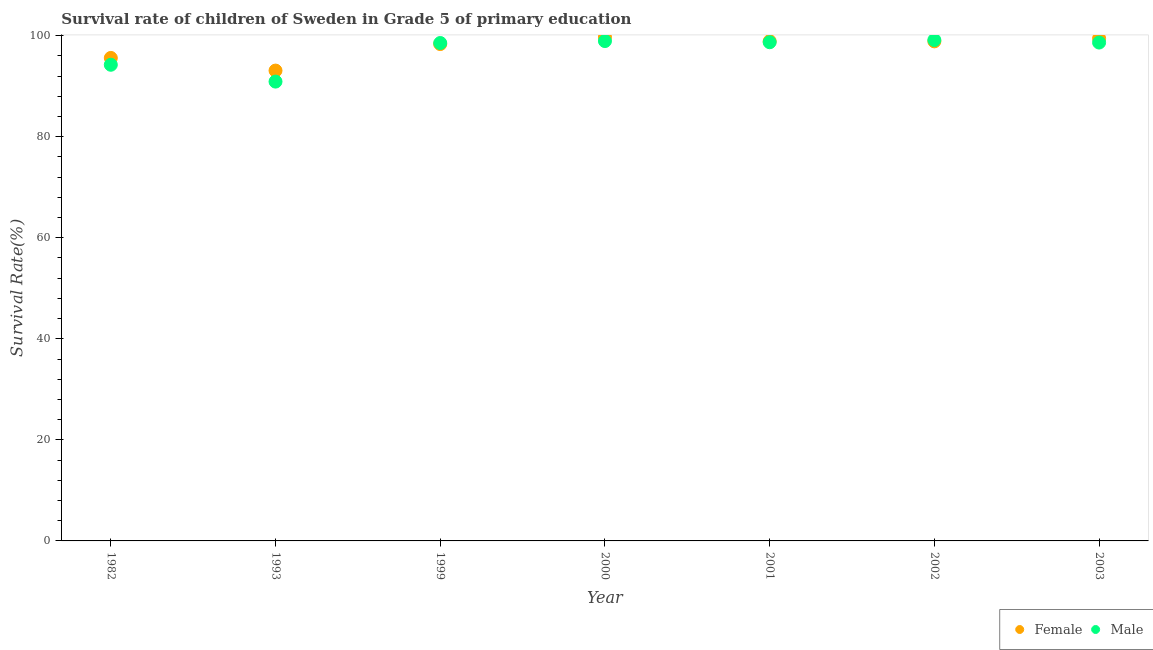How many different coloured dotlines are there?
Your answer should be very brief. 2. What is the survival rate of female students in primary education in 2001?
Keep it short and to the point. 98.9. Across all years, what is the maximum survival rate of female students in primary education?
Your response must be concise. 99.7. Across all years, what is the minimum survival rate of male students in primary education?
Provide a succinct answer. 90.9. What is the total survival rate of male students in primary education in the graph?
Your answer should be compact. 679.03. What is the difference between the survival rate of male students in primary education in 1982 and that in 2000?
Keep it short and to the point. -4.69. What is the difference between the survival rate of male students in primary education in 1982 and the survival rate of female students in primary education in 2001?
Ensure brevity in your answer.  -4.67. What is the average survival rate of female students in primary education per year?
Your answer should be very brief. 97.7. In the year 1982, what is the difference between the survival rate of male students in primary education and survival rate of female students in primary education?
Ensure brevity in your answer.  -1.35. In how many years, is the survival rate of female students in primary education greater than 64 %?
Offer a terse response. 7. What is the ratio of the survival rate of male students in primary education in 2000 to that in 2003?
Give a very brief answer. 1. Is the survival rate of female students in primary education in 2001 less than that in 2003?
Your response must be concise. Yes. What is the difference between the highest and the second highest survival rate of female students in primary education?
Provide a short and direct response. 0.26. What is the difference between the highest and the lowest survival rate of male students in primary education?
Your answer should be compact. 8.23. In how many years, is the survival rate of female students in primary education greater than the average survival rate of female students in primary education taken over all years?
Keep it short and to the point. 5. Does the survival rate of male students in primary education monotonically increase over the years?
Your response must be concise. No. Is the survival rate of female students in primary education strictly greater than the survival rate of male students in primary education over the years?
Offer a terse response. No. How many dotlines are there?
Offer a very short reply. 2. How many years are there in the graph?
Provide a succinct answer. 7. What is the difference between two consecutive major ticks on the Y-axis?
Make the answer very short. 20. How are the legend labels stacked?
Offer a terse response. Horizontal. What is the title of the graph?
Make the answer very short. Survival rate of children of Sweden in Grade 5 of primary education. Does "Lowest 20% of population" appear as one of the legend labels in the graph?
Offer a very short reply. No. What is the label or title of the Y-axis?
Offer a terse response. Survival Rate(%). What is the Survival Rate(%) of Female in 1982?
Your answer should be compact. 95.58. What is the Survival Rate(%) in Male in 1982?
Make the answer very short. 94.23. What is the Survival Rate(%) in Female in 1993?
Your answer should be compact. 93.08. What is the Survival Rate(%) in Male in 1993?
Offer a very short reply. 90.9. What is the Survival Rate(%) of Female in 1999?
Your response must be concise. 98.33. What is the Survival Rate(%) in Male in 1999?
Keep it short and to the point. 98.54. What is the Survival Rate(%) of Female in 2000?
Ensure brevity in your answer.  99.7. What is the Survival Rate(%) in Male in 2000?
Keep it short and to the point. 98.92. What is the Survival Rate(%) of Female in 2001?
Ensure brevity in your answer.  98.9. What is the Survival Rate(%) in Male in 2001?
Offer a very short reply. 98.69. What is the Survival Rate(%) in Female in 2002?
Provide a succinct answer. 98.86. What is the Survival Rate(%) in Male in 2002?
Provide a succinct answer. 99.13. What is the Survival Rate(%) of Female in 2003?
Offer a very short reply. 99.45. What is the Survival Rate(%) in Male in 2003?
Your answer should be compact. 98.63. Across all years, what is the maximum Survival Rate(%) in Female?
Offer a very short reply. 99.7. Across all years, what is the maximum Survival Rate(%) in Male?
Ensure brevity in your answer.  99.13. Across all years, what is the minimum Survival Rate(%) of Female?
Your answer should be compact. 93.08. Across all years, what is the minimum Survival Rate(%) in Male?
Your response must be concise. 90.9. What is the total Survival Rate(%) of Female in the graph?
Offer a very short reply. 683.9. What is the total Survival Rate(%) of Male in the graph?
Give a very brief answer. 679.03. What is the difference between the Survival Rate(%) of Female in 1982 and that in 1993?
Your answer should be very brief. 2.5. What is the difference between the Survival Rate(%) in Male in 1982 and that in 1993?
Provide a short and direct response. 3.33. What is the difference between the Survival Rate(%) of Female in 1982 and that in 1999?
Offer a very short reply. -2.74. What is the difference between the Survival Rate(%) in Male in 1982 and that in 1999?
Offer a terse response. -4.3. What is the difference between the Survival Rate(%) of Female in 1982 and that in 2000?
Offer a very short reply. -4.12. What is the difference between the Survival Rate(%) of Male in 1982 and that in 2000?
Your answer should be compact. -4.69. What is the difference between the Survival Rate(%) in Female in 1982 and that in 2001?
Offer a very short reply. -3.31. What is the difference between the Survival Rate(%) in Male in 1982 and that in 2001?
Make the answer very short. -4.46. What is the difference between the Survival Rate(%) in Female in 1982 and that in 2002?
Provide a succinct answer. -3.28. What is the difference between the Survival Rate(%) in Male in 1982 and that in 2002?
Your response must be concise. -4.9. What is the difference between the Survival Rate(%) in Female in 1982 and that in 2003?
Your answer should be compact. -3.86. What is the difference between the Survival Rate(%) of Male in 1982 and that in 2003?
Ensure brevity in your answer.  -4.4. What is the difference between the Survival Rate(%) in Female in 1993 and that in 1999?
Your response must be concise. -5.25. What is the difference between the Survival Rate(%) in Male in 1993 and that in 1999?
Offer a very short reply. -7.64. What is the difference between the Survival Rate(%) in Female in 1993 and that in 2000?
Provide a short and direct response. -6.63. What is the difference between the Survival Rate(%) in Male in 1993 and that in 2000?
Your answer should be compact. -8.02. What is the difference between the Survival Rate(%) of Female in 1993 and that in 2001?
Your response must be concise. -5.82. What is the difference between the Survival Rate(%) in Male in 1993 and that in 2001?
Make the answer very short. -7.79. What is the difference between the Survival Rate(%) of Female in 1993 and that in 2002?
Give a very brief answer. -5.78. What is the difference between the Survival Rate(%) of Male in 1993 and that in 2002?
Ensure brevity in your answer.  -8.23. What is the difference between the Survival Rate(%) of Female in 1993 and that in 2003?
Keep it short and to the point. -6.37. What is the difference between the Survival Rate(%) in Male in 1993 and that in 2003?
Your response must be concise. -7.73. What is the difference between the Survival Rate(%) in Female in 1999 and that in 2000?
Make the answer very short. -1.38. What is the difference between the Survival Rate(%) of Male in 1999 and that in 2000?
Your answer should be very brief. -0.39. What is the difference between the Survival Rate(%) of Female in 1999 and that in 2001?
Provide a succinct answer. -0.57. What is the difference between the Survival Rate(%) of Male in 1999 and that in 2001?
Offer a terse response. -0.15. What is the difference between the Survival Rate(%) of Female in 1999 and that in 2002?
Give a very brief answer. -0.54. What is the difference between the Survival Rate(%) in Male in 1999 and that in 2002?
Offer a terse response. -0.59. What is the difference between the Survival Rate(%) in Female in 1999 and that in 2003?
Provide a succinct answer. -1.12. What is the difference between the Survival Rate(%) of Male in 1999 and that in 2003?
Your answer should be compact. -0.09. What is the difference between the Survival Rate(%) in Female in 2000 and that in 2001?
Offer a very short reply. 0.81. What is the difference between the Survival Rate(%) in Male in 2000 and that in 2001?
Give a very brief answer. 0.23. What is the difference between the Survival Rate(%) of Female in 2000 and that in 2002?
Provide a short and direct response. 0.84. What is the difference between the Survival Rate(%) of Male in 2000 and that in 2002?
Ensure brevity in your answer.  -0.21. What is the difference between the Survival Rate(%) in Female in 2000 and that in 2003?
Your answer should be compact. 0.26. What is the difference between the Survival Rate(%) in Male in 2000 and that in 2003?
Ensure brevity in your answer.  0.29. What is the difference between the Survival Rate(%) in Female in 2001 and that in 2002?
Ensure brevity in your answer.  0.04. What is the difference between the Survival Rate(%) in Male in 2001 and that in 2002?
Your response must be concise. -0.44. What is the difference between the Survival Rate(%) of Female in 2001 and that in 2003?
Provide a short and direct response. -0.55. What is the difference between the Survival Rate(%) in Male in 2001 and that in 2003?
Provide a short and direct response. 0.06. What is the difference between the Survival Rate(%) in Female in 2002 and that in 2003?
Keep it short and to the point. -0.58. What is the difference between the Survival Rate(%) of Male in 2002 and that in 2003?
Your answer should be compact. 0.5. What is the difference between the Survival Rate(%) of Female in 1982 and the Survival Rate(%) of Male in 1993?
Your answer should be compact. 4.68. What is the difference between the Survival Rate(%) in Female in 1982 and the Survival Rate(%) in Male in 1999?
Provide a succinct answer. -2.95. What is the difference between the Survival Rate(%) in Female in 1982 and the Survival Rate(%) in Male in 2000?
Your response must be concise. -3.34. What is the difference between the Survival Rate(%) of Female in 1982 and the Survival Rate(%) of Male in 2001?
Offer a very short reply. -3.1. What is the difference between the Survival Rate(%) of Female in 1982 and the Survival Rate(%) of Male in 2002?
Your response must be concise. -3.54. What is the difference between the Survival Rate(%) in Female in 1982 and the Survival Rate(%) in Male in 2003?
Keep it short and to the point. -3.04. What is the difference between the Survival Rate(%) of Female in 1993 and the Survival Rate(%) of Male in 1999?
Provide a succinct answer. -5.46. What is the difference between the Survival Rate(%) of Female in 1993 and the Survival Rate(%) of Male in 2000?
Ensure brevity in your answer.  -5.84. What is the difference between the Survival Rate(%) in Female in 1993 and the Survival Rate(%) in Male in 2001?
Provide a short and direct response. -5.61. What is the difference between the Survival Rate(%) of Female in 1993 and the Survival Rate(%) of Male in 2002?
Your response must be concise. -6.05. What is the difference between the Survival Rate(%) of Female in 1993 and the Survival Rate(%) of Male in 2003?
Provide a succinct answer. -5.55. What is the difference between the Survival Rate(%) of Female in 1999 and the Survival Rate(%) of Male in 2000?
Your response must be concise. -0.6. What is the difference between the Survival Rate(%) of Female in 1999 and the Survival Rate(%) of Male in 2001?
Give a very brief answer. -0.36. What is the difference between the Survival Rate(%) in Female in 1999 and the Survival Rate(%) in Male in 2002?
Your answer should be very brief. -0.8. What is the difference between the Survival Rate(%) in Female in 1999 and the Survival Rate(%) in Male in 2003?
Give a very brief answer. -0.3. What is the difference between the Survival Rate(%) of Female in 2000 and the Survival Rate(%) of Male in 2001?
Provide a succinct answer. 1.02. What is the difference between the Survival Rate(%) in Female in 2000 and the Survival Rate(%) in Male in 2002?
Make the answer very short. 0.58. What is the difference between the Survival Rate(%) in Female in 2000 and the Survival Rate(%) in Male in 2003?
Your answer should be very brief. 1.08. What is the difference between the Survival Rate(%) in Female in 2001 and the Survival Rate(%) in Male in 2002?
Your answer should be compact. -0.23. What is the difference between the Survival Rate(%) in Female in 2001 and the Survival Rate(%) in Male in 2003?
Make the answer very short. 0.27. What is the difference between the Survival Rate(%) in Female in 2002 and the Survival Rate(%) in Male in 2003?
Offer a terse response. 0.23. What is the average Survival Rate(%) in Female per year?
Provide a succinct answer. 97.7. What is the average Survival Rate(%) of Male per year?
Offer a very short reply. 97. In the year 1982, what is the difference between the Survival Rate(%) of Female and Survival Rate(%) of Male?
Offer a terse response. 1.35. In the year 1993, what is the difference between the Survival Rate(%) of Female and Survival Rate(%) of Male?
Give a very brief answer. 2.18. In the year 1999, what is the difference between the Survival Rate(%) in Female and Survival Rate(%) in Male?
Keep it short and to the point. -0.21. In the year 2000, what is the difference between the Survival Rate(%) in Female and Survival Rate(%) in Male?
Provide a short and direct response. 0.78. In the year 2001, what is the difference between the Survival Rate(%) in Female and Survival Rate(%) in Male?
Make the answer very short. 0.21. In the year 2002, what is the difference between the Survival Rate(%) of Female and Survival Rate(%) of Male?
Your answer should be very brief. -0.27. In the year 2003, what is the difference between the Survival Rate(%) in Female and Survival Rate(%) in Male?
Offer a very short reply. 0.82. What is the ratio of the Survival Rate(%) of Female in 1982 to that in 1993?
Offer a terse response. 1.03. What is the ratio of the Survival Rate(%) in Male in 1982 to that in 1993?
Your response must be concise. 1.04. What is the ratio of the Survival Rate(%) of Female in 1982 to that in 1999?
Your response must be concise. 0.97. What is the ratio of the Survival Rate(%) of Male in 1982 to that in 1999?
Your response must be concise. 0.96. What is the ratio of the Survival Rate(%) in Female in 1982 to that in 2000?
Provide a succinct answer. 0.96. What is the ratio of the Survival Rate(%) in Male in 1982 to that in 2000?
Your answer should be compact. 0.95. What is the ratio of the Survival Rate(%) of Female in 1982 to that in 2001?
Your answer should be compact. 0.97. What is the ratio of the Survival Rate(%) of Male in 1982 to that in 2001?
Provide a succinct answer. 0.95. What is the ratio of the Survival Rate(%) of Female in 1982 to that in 2002?
Give a very brief answer. 0.97. What is the ratio of the Survival Rate(%) in Male in 1982 to that in 2002?
Make the answer very short. 0.95. What is the ratio of the Survival Rate(%) of Female in 1982 to that in 2003?
Your answer should be very brief. 0.96. What is the ratio of the Survival Rate(%) of Male in 1982 to that in 2003?
Offer a terse response. 0.96. What is the ratio of the Survival Rate(%) of Female in 1993 to that in 1999?
Your answer should be very brief. 0.95. What is the ratio of the Survival Rate(%) in Male in 1993 to that in 1999?
Make the answer very short. 0.92. What is the ratio of the Survival Rate(%) of Female in 1993 to that in 2000?
Make the answer very short. 0.93. What is the ratio of the Survival Rate(%) in Male in 1993 to that in 2000?
Your answer should be very brief. 0.92. What is the ratio of the Survival Rate(%) in Male in 1993 to that in 2001?
Keep it short and to the point. 0.92. What is the ratio of the Survival Rate(%) in Female in 1993 to that in 2002?
Offer a terse response. 0.94. What is the ratio of the Survival Rate(%) of Male in 1993 to that in 2002?
Offer a terse response. 0.92. What is the ratio of the Survival Rate(%) in Female in 1993 to that in 2003?
Give a very brief answer. 0.94. What is the ratio of the Survival Rate(%) in Male in 1993 to that in 2003?
Your answer should be compact. 0.92. What is the ratio of the Survival Rate(%) of Female in 1999 to that in 2000?
Offer a very short reply. 0.99. What is the ratio of the Survival Rate(%) in Male in 1999 to that in 2000?
Give a very brief answer. 1. What is the ratio of the Survival Rate(%) in Male in 1999 to that in 2001?
Ensure brevity in your answer.  1. What is the ratio of the Survival Rate(%) in Female in 1999 to that in 2002?
Provide a succinct answer. 0.99. What is the ratio of the Survival Rate(%) of Male in 1999 to that in 2002?
Your response must be concise. 0.99. What is the ratio of the Survival Rate(%) in Female in 1999 to that in 2003?
Ensure brevity in your answer.  0.99. What is the ratio of the Survival Rate(%) in Male in 1999 to that in 2003?
Your answer should be very brief. 1. What is the ratio of the Survival Rate(%) of Female in 2000 to that in 2001?
Your answer should be compact. 1.01. What is the ratio of the Survival Rate(%) in Female in 2000 to that in 2002?
Make the answer very short. 1.01. What is the ratio of the Survival Rate(%) of Male in 2000 to that in 2002?
Offer a very short reply. 1. What is the ratio of the Survival Rate(%) in Female in 2000 to that in 2003?
Keep it short and to the point. 1. What is the ratio of the Survival Rate(%) in Female in 2001 to that in 2002?
Provide a succinct answer. 1. What is the ratio of the Survival Rate(%) in Female in 2001 to that in 2003?
Offer a terse response. 0.99. What is the ratio of the Survival Rate(%) of Female in 2002 to that in 2003?
Make the answer very short. 0.99. What is the difference between the highest and the second highest Survival Rate(%) of Female?
Give a very brief answer. 0.26. What is the difference between the highest and the second highest Survival Rate(%) in Male?
Give a very brief answer. 0.21. What is the difference between the highest and the lowest Survival Rate(%) in Female?
Keep it short and to the point. 6.63. What is the difference between the highest and the lowest Survival Rate(%) in Male?
Give a very brief answer. 8.23. 